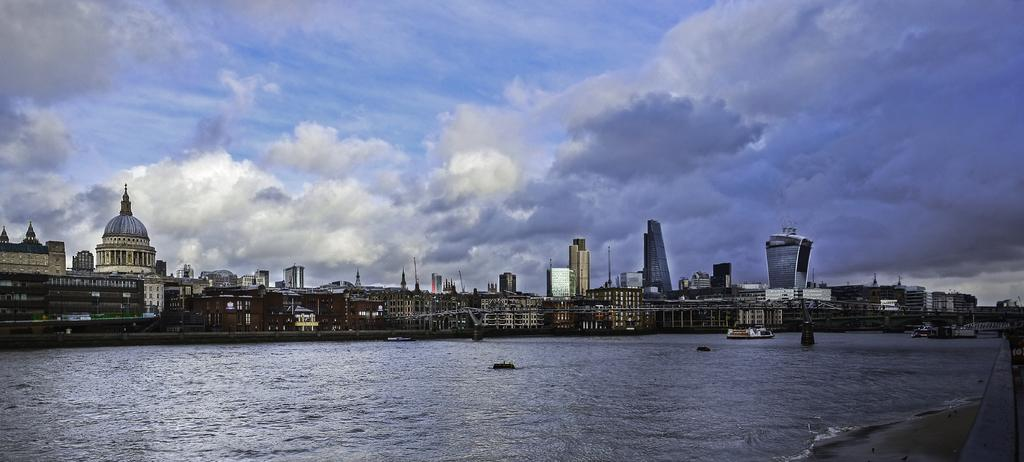What type of location is shown in the image? The image depicts a beach. What structures can be seen in the middle of the image? There are buildings in the middle of the image. What can be seen in the sky in the image? Clouds are visible in the sky. What type of road can be seen leading to the beach in the image? There is no road visible in the image; it depicts a beach with buildings and clouds in the sky. Is there a sweater hanging on the buildings in the image? There is no sweater present in the image; it only shows a beach, buildings, and clouds in the sky. 